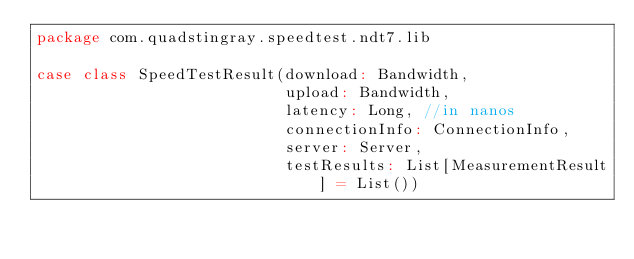Convert code to text. <code><loc_0><loc_0><loc_500><loc_500><_Scala_>package com.quadstingray.speedtest.ndt7.lib

case class SpeedTestResult(download: Bandwidth,
                           upload: Bandwidth,
                           latency: Long, //in nanos
                           connectionInfo: ConnectionInfo,
                           server: Server,
                           testResults: List[MeasurementResult] = List())
</code> 